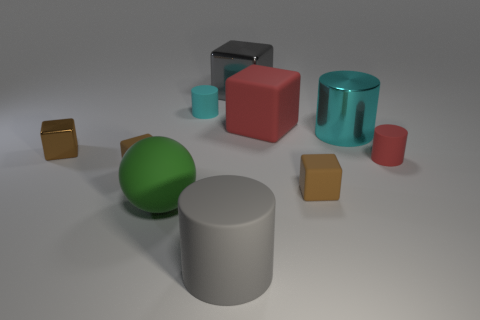There is a gray thing that is in front of the small red matte object; what is its shape?
Keep it short and to the point. Cylinder. Is there another cylinder that has the same color as the big matte cylinder?
Offer a very short reply. No. Is the size of the gray metallic object behind the small red object the same as the metallic object that is left of the large gray metallic thing?
Provide a short and direct response. No. Are there more cyan matte things to the left of the ball than big green spheres that are on the right side of the red matte cylinder?
Provide a short and direct response. No. Is there a cyan cylinder that has the same material as the red block?
Give a very brief answer. Yes. Do the small shiny thing and the sphere have the same color?
Your answer should be very brief. No. What is the material of the cylinder that is both in front of the cyan metallic cylinder and on the left side of the big gray shiny block?
Your answer should be very brief. Rubber. What color is the rubber sphere?
Make the answer very short. Green. How many small brown matte things are the same shape as the large green rubber object?
Give a very brief answer. 0. Are the small cylinder in front of the red rubber cube and the big cylinder that is in front of the small metal thing made of the same material?
Your answer should be compact. Yes. 